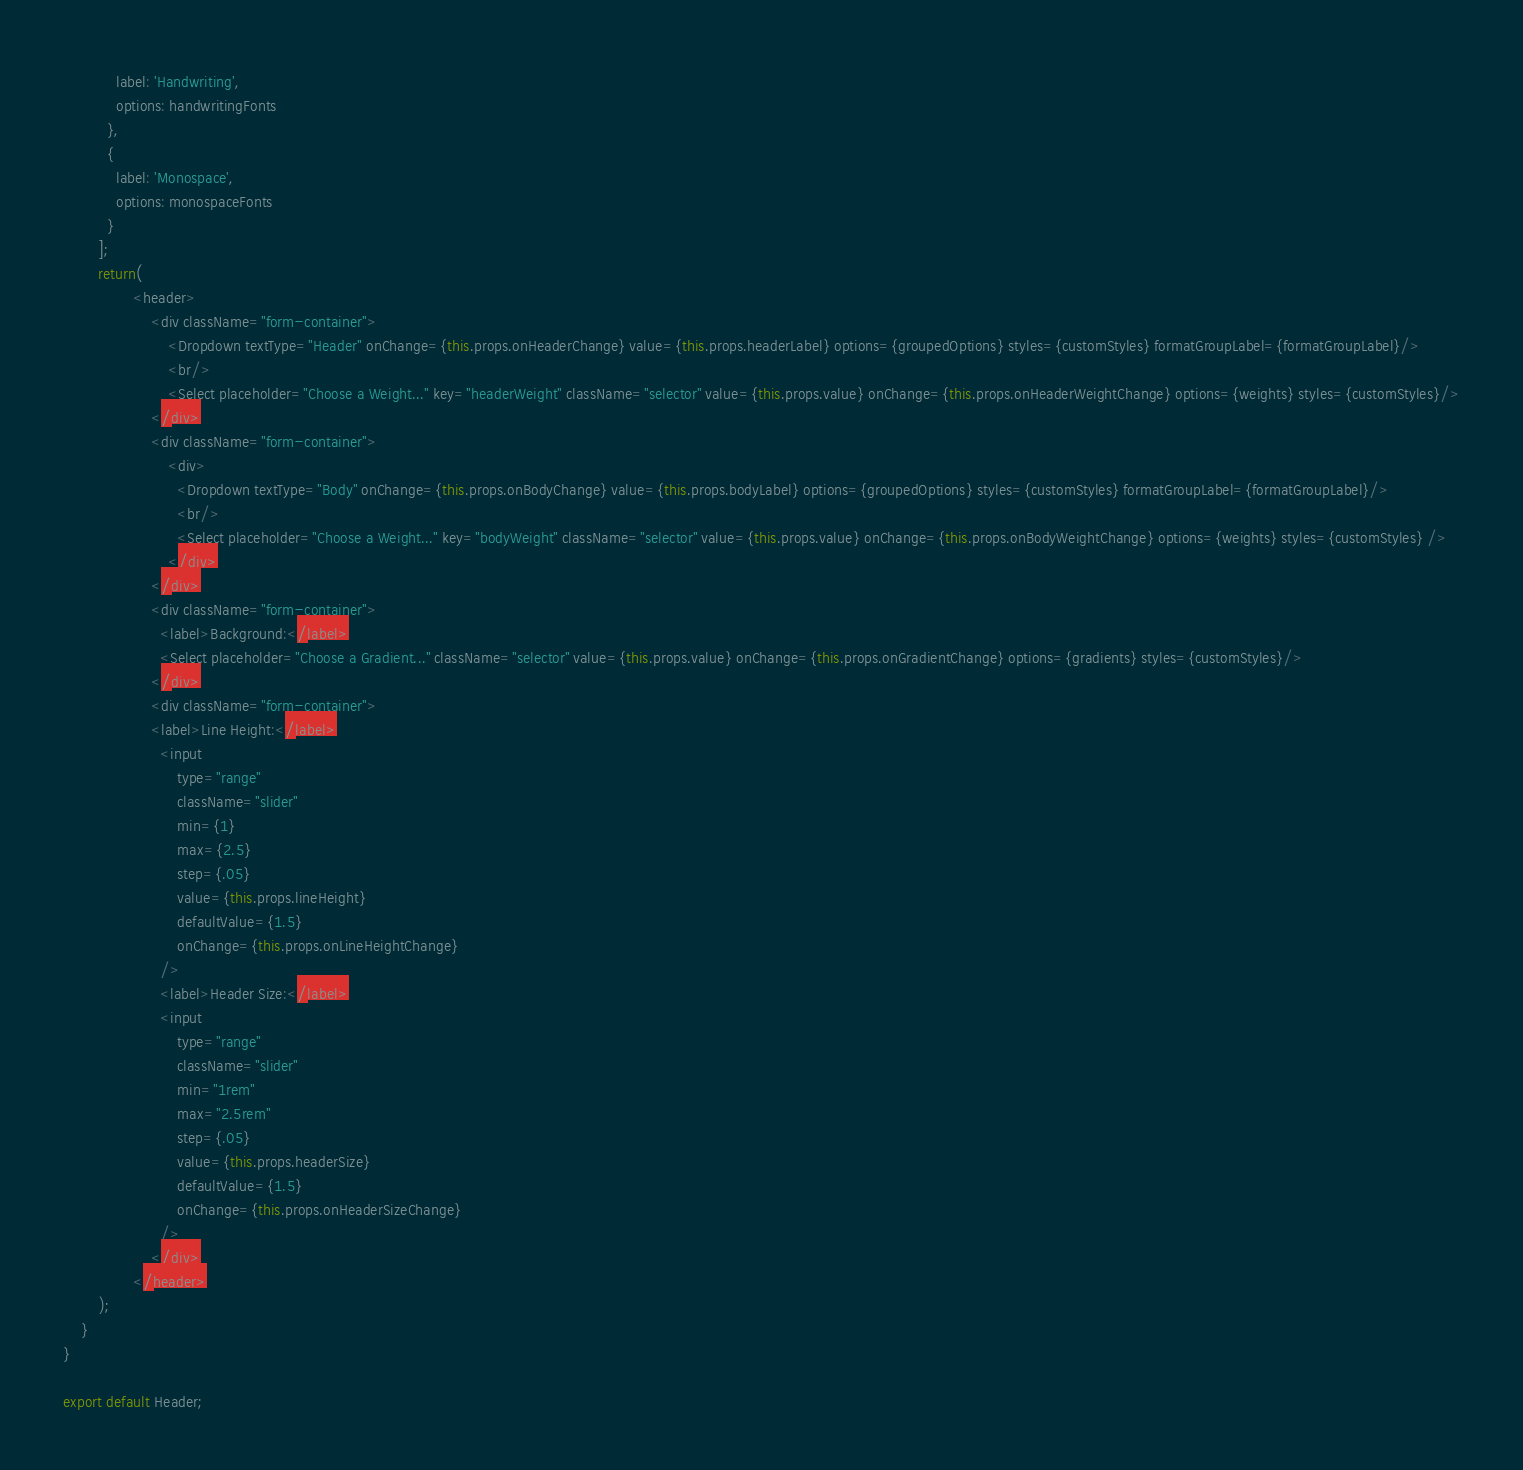Convert code to text. <code><loc_0><loc_0><loc_500><loc_500><_JavaScript_>            label: 'Handwriting',
            options: handwritingFonts
          },
          {
            label: 'Monospace',
            options: monospaceFonts
          }
        ];
        return(
                <header>
                    <div className="form-container">
                        <Dropdown textType="Header" onChange={this.props.onHeaderChange} value={this.props.headerLabel} options={groupedOptions} styles={customStyles} formatGroupLabel={formatGroupLabel}/>
                        <br/>
                        <Select placeholder="Choose a Weight..." key="headerWeight" className="selector" value={this.props.value} onChange={this.props.onHeaderWeightChange} options={weights} styles={customStyles}/>
                    </div>
                    <div className="form-container">
                        <div>
                          <Dropdown textType="Body" onChange={this.props.onBodyChange} value={this.props.bodyLabel} options={groupedOptions} styles={customStyles} formatGroupLabel={formatGroupLabel}/>
                          <br/>
                          <Select placeholder="Choose a Weight..." key="bodyWeight" className="selector" value={this.props.value} onChange={this.props.onBodyWeightChange} options={weights} styles={customStyles} />
                        </div>
                    </div>
                    <div className="form-container">
                      <label>Background:</label>
                      <Select placeholder="Choose a Gradient..." className="selector" value={this.props.value} onChange={this.props.onGradientChange} options={gradients} styles={customStyles}/>
                    </div>
                    <div className="form-container">
                    <label>Line Height:</label>
                      <input 
                          type="range"
                          className="slider"
                          min={1}
                          max={2.5}
                          step={.05}
                          value={this.props.lineHeight}
                          defaultValue={1.5}
                          onChange={this.props.onLineHeightChange}
                      />
                      <label>Header Size:</label>
                      <input 
                          type="range"
                          className="slider"
                          min="1rem"
                          max="2.5rem"
                          step={.05}
                          value={this.props.headerSize}
                          defaultValue={1.5}
                          onChange={this.props.onHeaderSizeChange}
                      />
                    </div>
                </header>
        );
    }
}

export default Header;</code> 